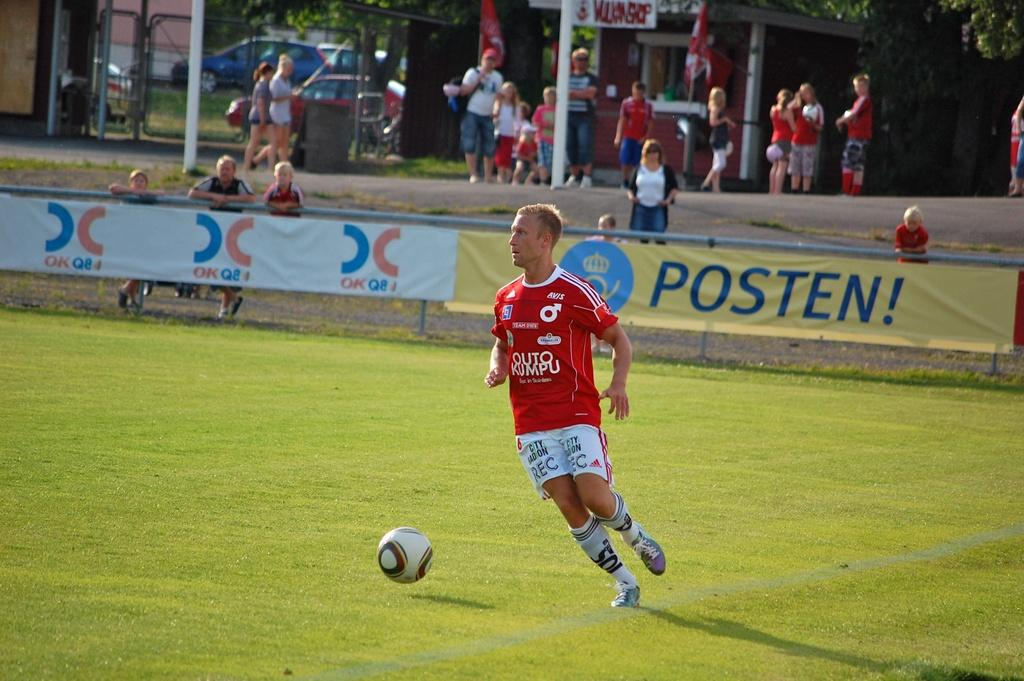<image>
Create a compact narrative representing the image presented. A yellow banner along the edge of the soccer field says POSTEN. 